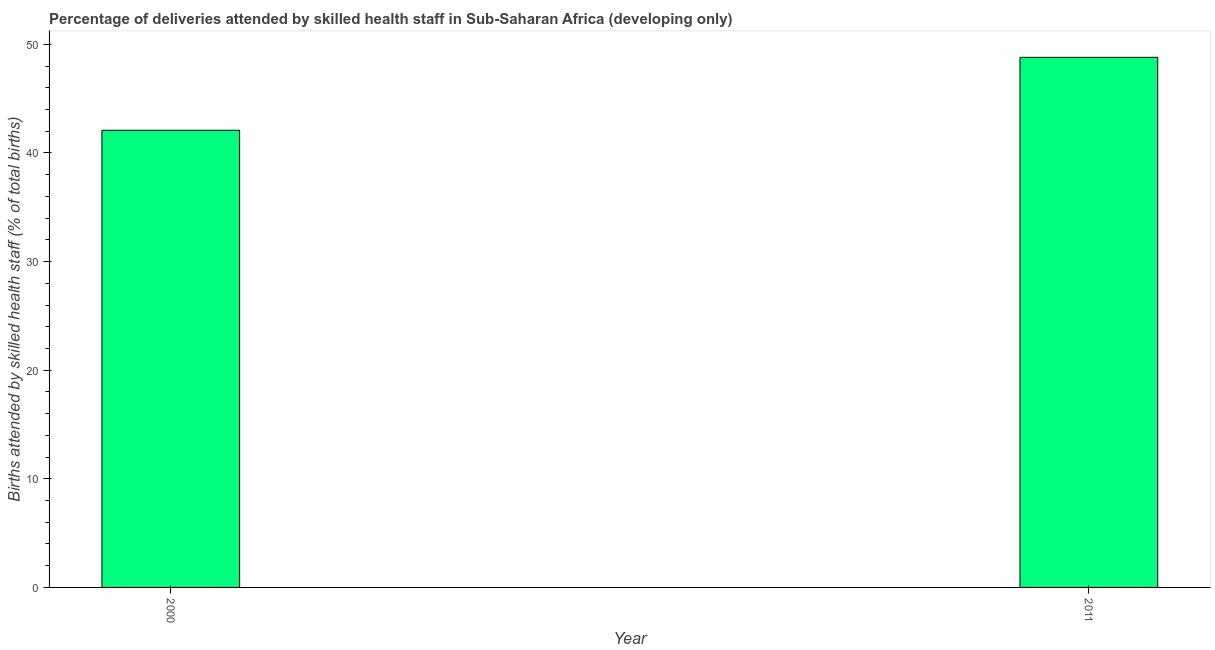What is the title of the graph?
Your response must be concise. Percentage of deliveries attended by skilled health staff in Sub-Saharan Africa (developing only). What is the label or title of the Y-axis?
Your answer should be compact. Births attended by skilled health staff (% of total births). What is the number of births attended by skilled health staff in 2011?
Give a very brief answer. 48.81. Across all years, what is the maximum number of births attended by skilled health staff?
Your answer should be compact. 48.81. Across all years, what is the minimum number of births attended by skilled health staff?
Your answer should be very brief. 42.09. In which year was the number of births attended by skilled health staff maximum?
Provide a short and direct response. 2011. What is the sum of the number of births attended by skilled health staff?
Give a very brief answer. 90.9. What is the difference between the number of births attended by skilled health staff in 2000 and 2011?
Your answer should be very brief. -6.72. What is the average number of births attended by skilled health staff per year?
Provide a succinct answer. 45.45. What is the median number of births attended by skilled health staff?
Your answer should be very brief. 45.45. Do a majority of the years between 2000 and 2011 (inclusive) have number of births attended by skilled health staff greater than 28 %?
Give a very brief answer. Yes. What is the ratio of the number of births attended by skilled health staff in 2000 to that in 2011?
Keep it short and to the point. 0.86. Are the values on the major ticks of Y-axis written in scientific E-notation?
Provide a succinct answer. No. What is the Births attended by skilled health staff (% of total births) of 2000?
Ensure brevity in your answer.  42.09. What is the Births attended by skilled health staff (% of total births) in 2011?
Ensure brevity in your answer.  48.81. What is the difference between the Births attended by skilled health staff (% of total births) in 2000 and 2011?
Offer a terse response. -6.72. What is the ratio of the Births attended by skilled health staff (% of total births) in 2000 to that in 2011?
Offer a terse response. 0.86. 